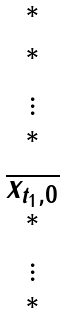<formula> <loc_0><loc_0><loc_500><loc_500>\begin{matrix} ^ { * } \\ ^ { * } \\ \vdots \\ ^ { * } \\ \overline { x _ { t _ { 1 } , 0 } } \\ ^ { * } \\ \vdots \\ ^ { * } \end{matrix}</formula> 